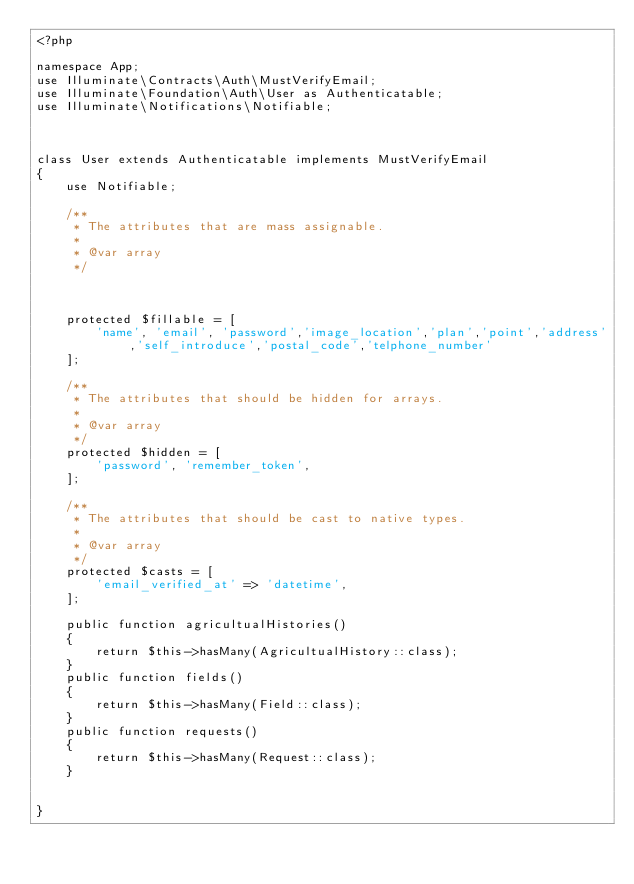Convert code to text. <code><loc_0><loc_0><loc_500><loc_500><_PHP_><?php

namespace App;
use Illuminate\Contracts\Auth\MustVerifyEmail;
use Illuminate\Foundation\Auth\User as Authenticatable;
use Illuminate\Notifications\Notifiable;



class User extends Authenticatable implements MustVerifyEmail
{
    use Notifiable;

    /**
     * The attributes that are mass assignable.
     *
     * @var array
     */
     
   
    
    protected $fillable = [
        'name', 'email', 'password','image_location','plan','point','address','self_introduce','postal_code','telphone_number'
    ];

    /**
     * The attributes that should be hidden for arrays.
     *
     * @var array
     */
    protected $hidden = [
        'password', 'remember_token',
    ];

    /**
     * The attributes that should be cast to native types.
     *
     * @var array
     */
    protected $casts = [
        'email_verified_at' => 'datetime',
    ];
    
    public function agricultualHistories()
    {
        return $this->hasMany(AgricultualHistory::class);
    }
    public function fields()
    {
        return $this->hasMany(Field::class);
    }
    public function requests()
    {
        return $this->hasMany(Request::class);
    }
    
    
}
</code> 